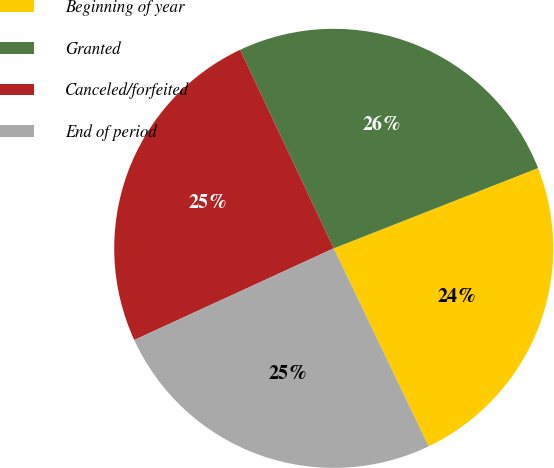<chart> <loc_0><loc_0><loc_500><loc_500><pie_chart><fcel>Beginning of year<fcel>Granted<fcel>Canceled/forfeited<fcel>End of period<nl><fcel>23.84%<fcel>26.05%<fcel>24.84%<fcel>25.26%<nl></chart> 